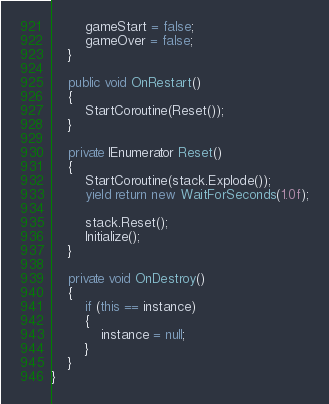<code> <loc_0><loc_0><loc_500><loc_500><_C#_>        gameStart = false;
        gameOver = false;
    }

    public void OnRestart()
    {
        StartCoroutine(Reset());
    }

    private IEnumerator Reset()
    {
        StartCoroutine(stack.Explode());
        yield return new WaitForSeconds(1.0f);

        stack.Reset();
        Initialize();
    }

    private void OnDestroy()
    {
        if (this == instance)
        {
            instance = null;
        }
    }
}
</code> 